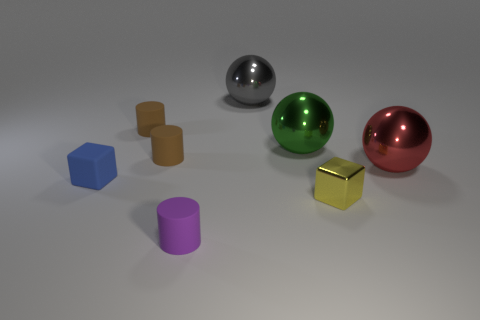How is lighting used to highlight the objects in the scene? The lighting in the scene is soft and diffuse, coming from above. It gently illuminates the objects, softening shadows and reducing harsh reflections, which enhances the visual texture and color of each item while maintaining a balanced composition overall.  Are shadows present in the image, and what do they tell us about the lighting? Yes, shadows are present beneath each object, indicating that the light source is located above. The shadows are soft-edged and elongate opposite the light source, suggesting a single point light that is somewhat distant from the objects. 